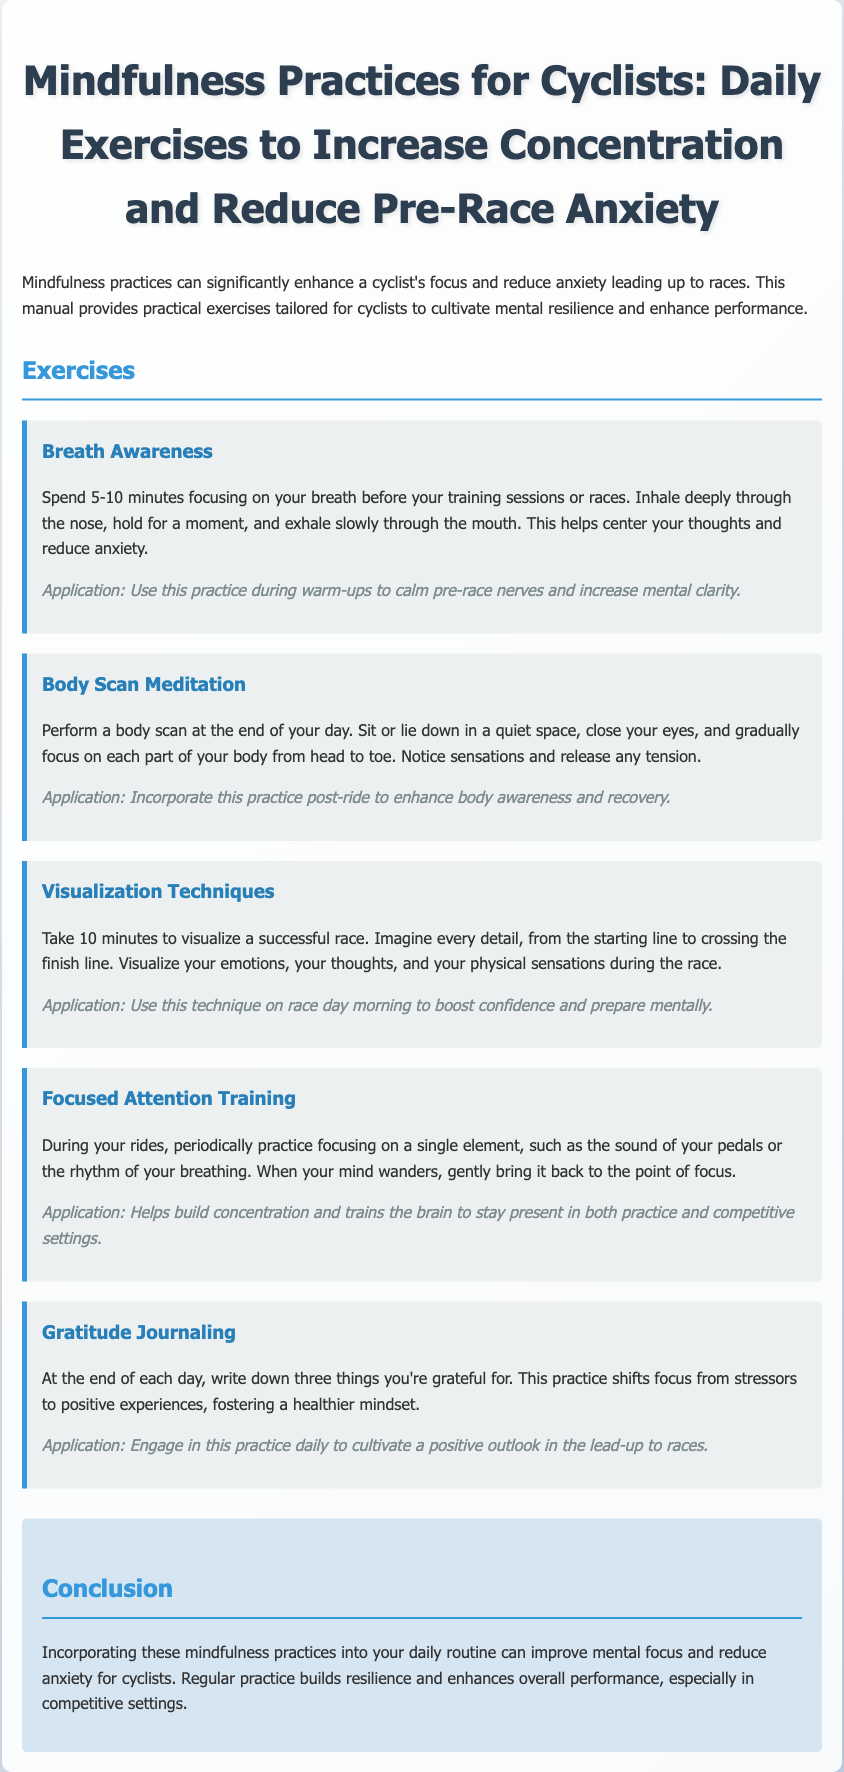What is the title of the manual? The title is mentioned prominently at the top of the document.
Answer: Mindfulness Practices for Cyclists: Daily Exercises to Increase Concentration and Reduce Pre-Race Anxiety How long should the Breath Awareness practice last? The recommended duration is specified in the description of the exercise.
Answer: 5-10 minutes What should you write in gratitude journaling? The manual specifies what to focus on in this exercise.
Answer: Three things you're grateful for Which mindfulness practice is suggested for post-ride? The application section of the Body Scan Meditation lists its post-ride utility.
Answer: Body Scan Meditation What is the purpose of Visualization Techniques? The goal of using this technique is described in the context of a race.
Answer: Boost confidence and prepare mentally How can focusing on a single element during rides help? The purpose is articulated in the application section of Focused Attention Training.
Answer: Build concentration What is a common application of all the exercises? The routine aspect is highlighted in the conclusion, referring to overall practice utility.
Answer: Daily routine What positive mindset does Gratitude Journaling foster? The application outlines the specific positive effect of the exercise.
Answer: Healthier mindset 